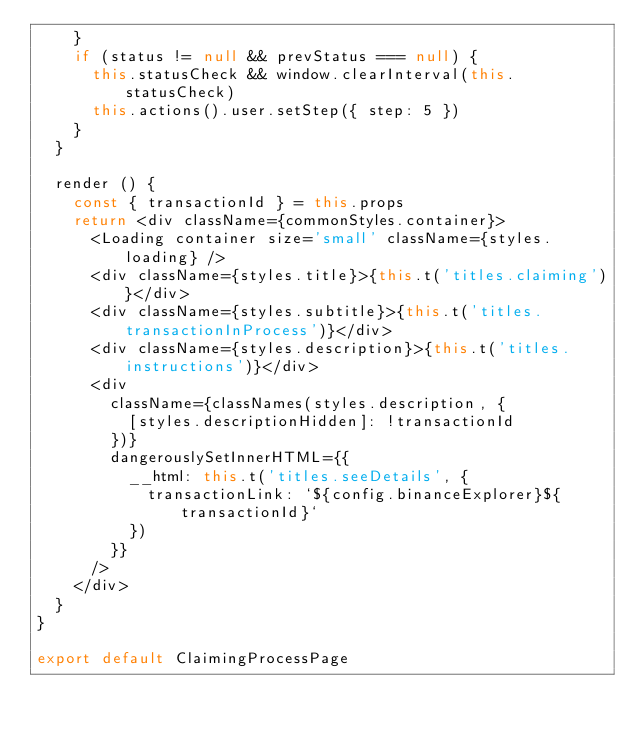Convert code to text. <code><loc_0><loc_0><loc_500><loc_500><_JavaScript_>    }
    if (status != null && prevStatus === null) {
      this.statusCheck && window.clearInterval(this.statusCheck)
      this.actions().user.setStep({ step: 5 })
    }
  }

  render () {
    const { transactionId } = this.props
    return <div className={commonStyles.container}>
      <Loading container size='small' className={styles.loading} />
      <div className={styles.title}>{this.t('titles.claiming')}</div>
      <div className={styles.subtitle}>{this.t('titles.transactionInProcess')}</div>
      <div className={styles.description}>{this.t('titles.instructions')}</div>
      <div
        className={classNames(styles.description, {
          [styles.descriptionHidden]: !transactionId
        })}
        dangerouslySetInnerHTML={{
          __html: this.t('titles.seeDetails', {
            transactionLink: `${config.binanceExplorer}${transactionId}`
          })
        }}
      />
    </div>
  }
}

export default ClaimingProcessPage
</code> 